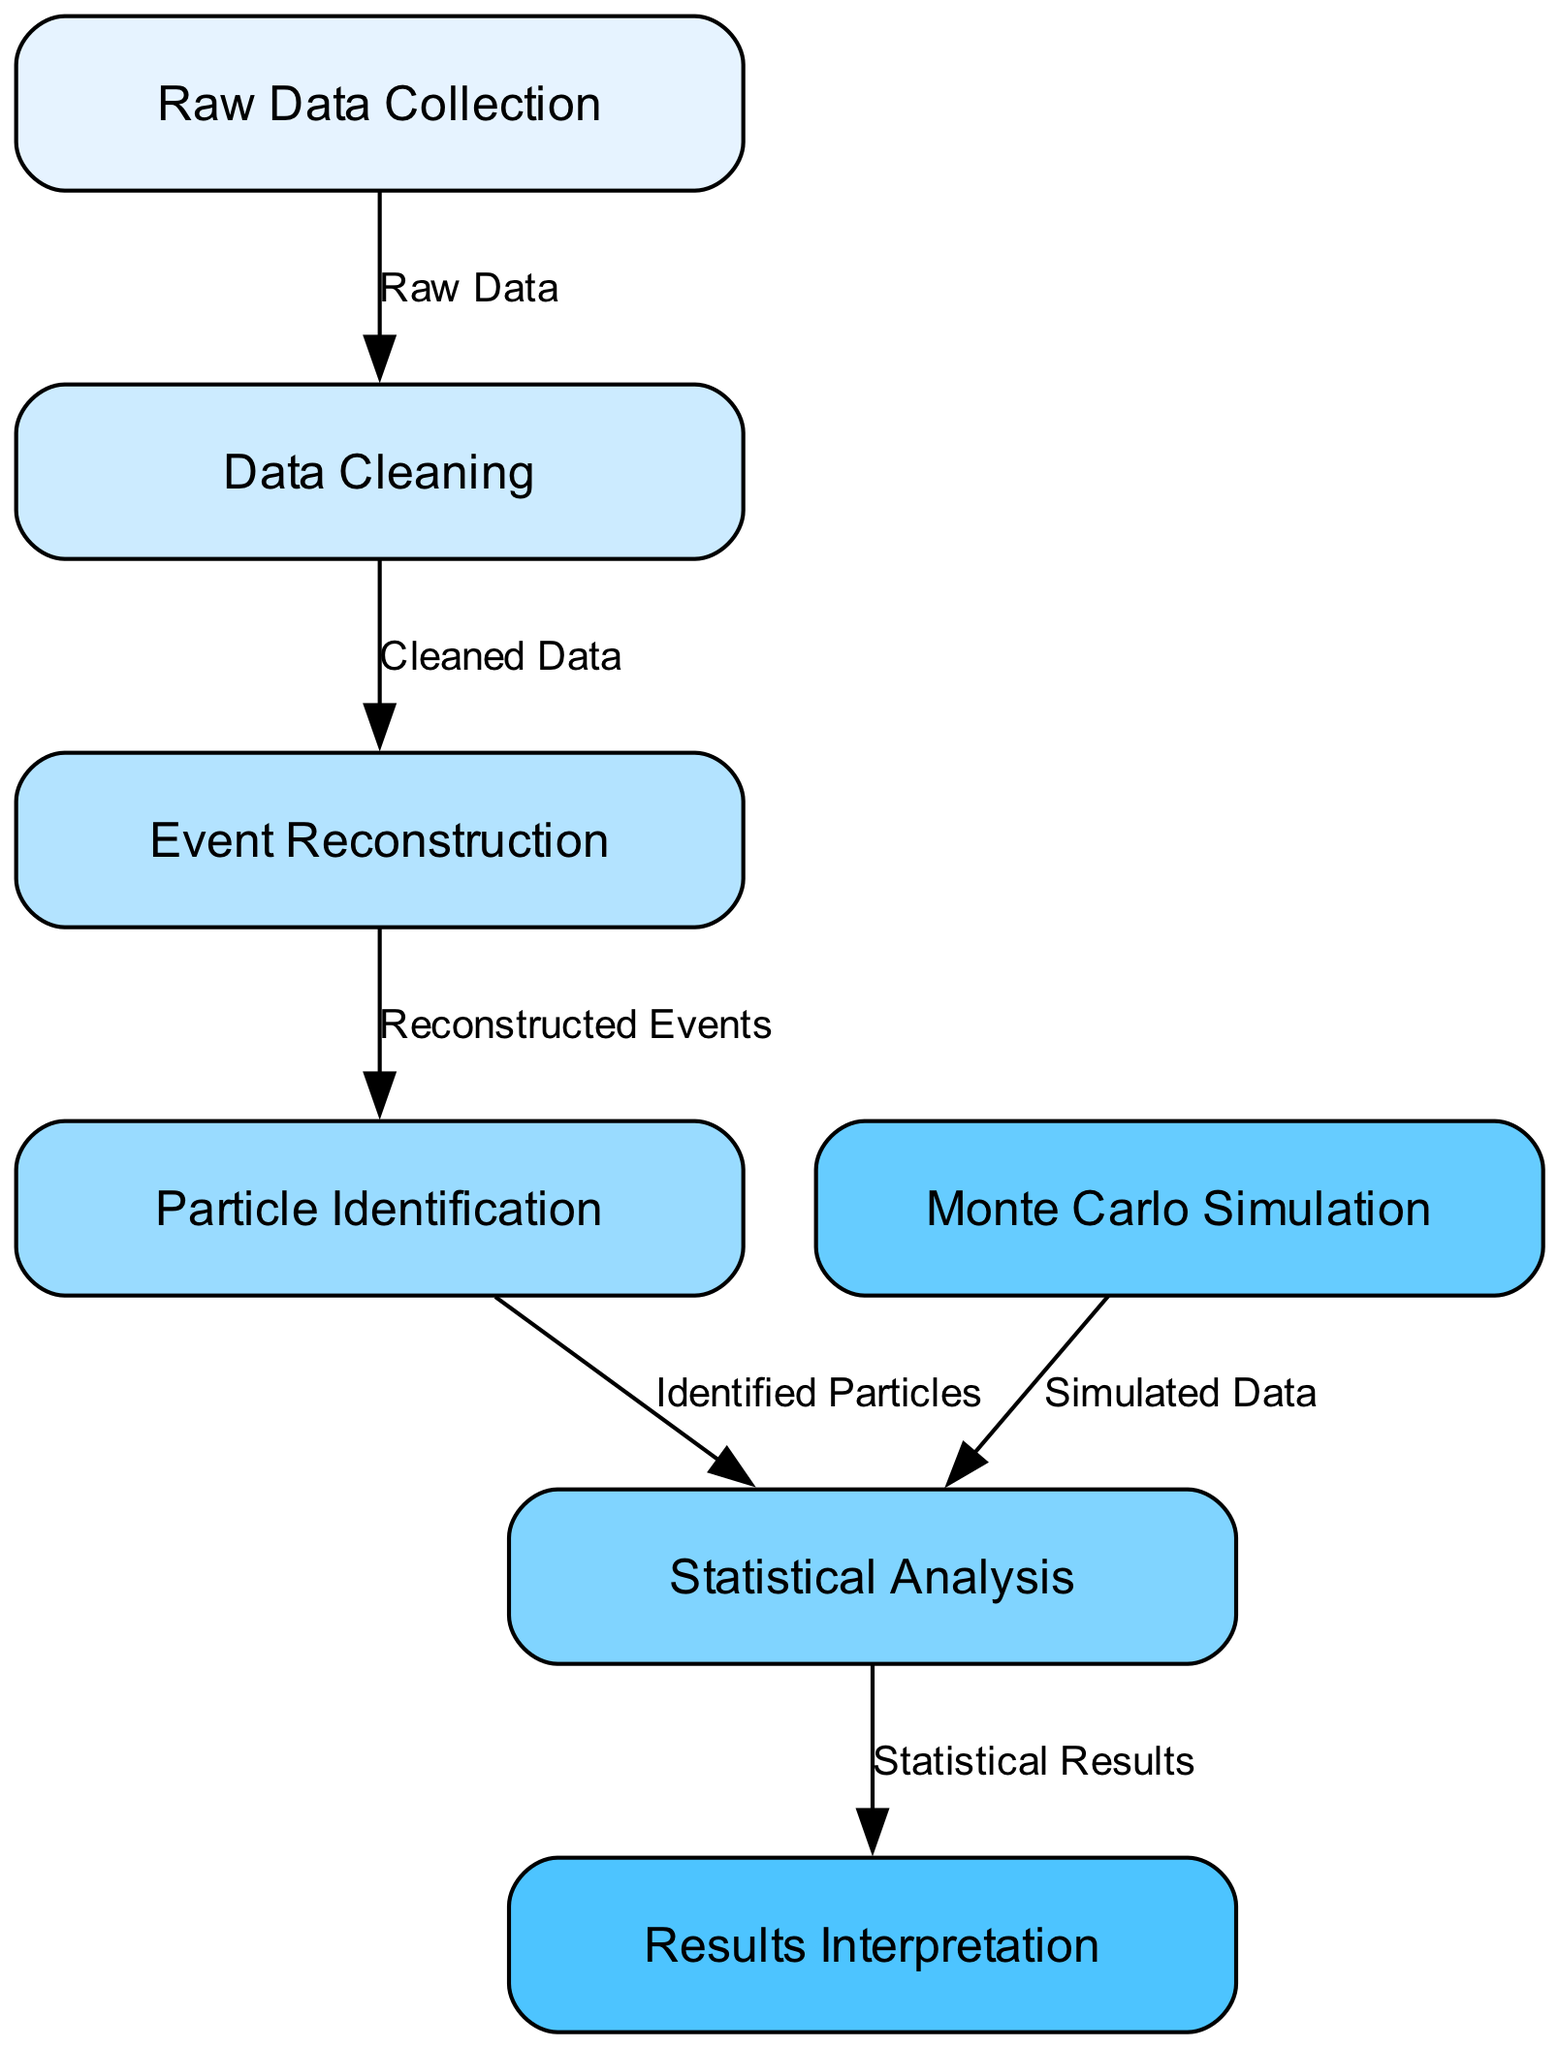What is the first step in the process flow? The first step in the process flow is represented by the node labeled "Raw Data Collection." This can be identified as the starting point of the diagram.
Answer: Raw Data Collection How many nodes are there in total? By counting the individual nodes listed in the diagram, there are seven distinct nodes that represent different stages of the data analysis process.
Answer: 7 What is the output of the "Data Cleaning" node? The "Data Cleaning" node outputs "Cleaned Data" as indicated by the edge that connects it to the next node in the flow. This is the direct label on the edge leading from Data Cleaning to Event Reconstruction.
Answer: Cleaned Data Which node immediately follows "Event Reconstruction"? The node that immediately follows "Event Reconstruction" is "Particle Identification," as represented by the edge connecting the two nodes sequentially in the diagram.
Answer: Particle Identification What type of data is fed into the "Statistical Analysis" node? The "Statistical Analysis" node receives two types of data: "Identified Particles" from "Particle Identification" and "Simulated Data" from "Monte Carlo Simulation," as shown by its connections.
Answer: Identified Particles and Simulated Data How are "Monte Carlo Simulation" and "Statistical Analysis" connected? "Monte Carlo Simulation" is connected to "Statistical Analysis" through an edge that represents “Simulated Data.” This identifies the relationship where the simulated data contributes to statistical analysis.
Answer: Simulated Data What is the final step in the process flow? The final step is the node labeled "Results Interpretation," which receives output from the "Statistical Analysis" node, making it the concluding stage in the diagram series.
Answer: Results Interpretation How many edges lead to the "Statistical Analysis" node? The "Statistical Analysis" node has two edges leading to it, one from "Particle Identification" and one from "Monte Carlo Simulation," indicating input from both sources.
Answer: 2 What is the primary function of the "Event Reconstruction" node? The primary function of the "Event Reconstruction" node is to process "Cleaned Data" into "Reconstructed Events," which is specified by the edge that connects to the following node.
Answer: Reconstructed Events 